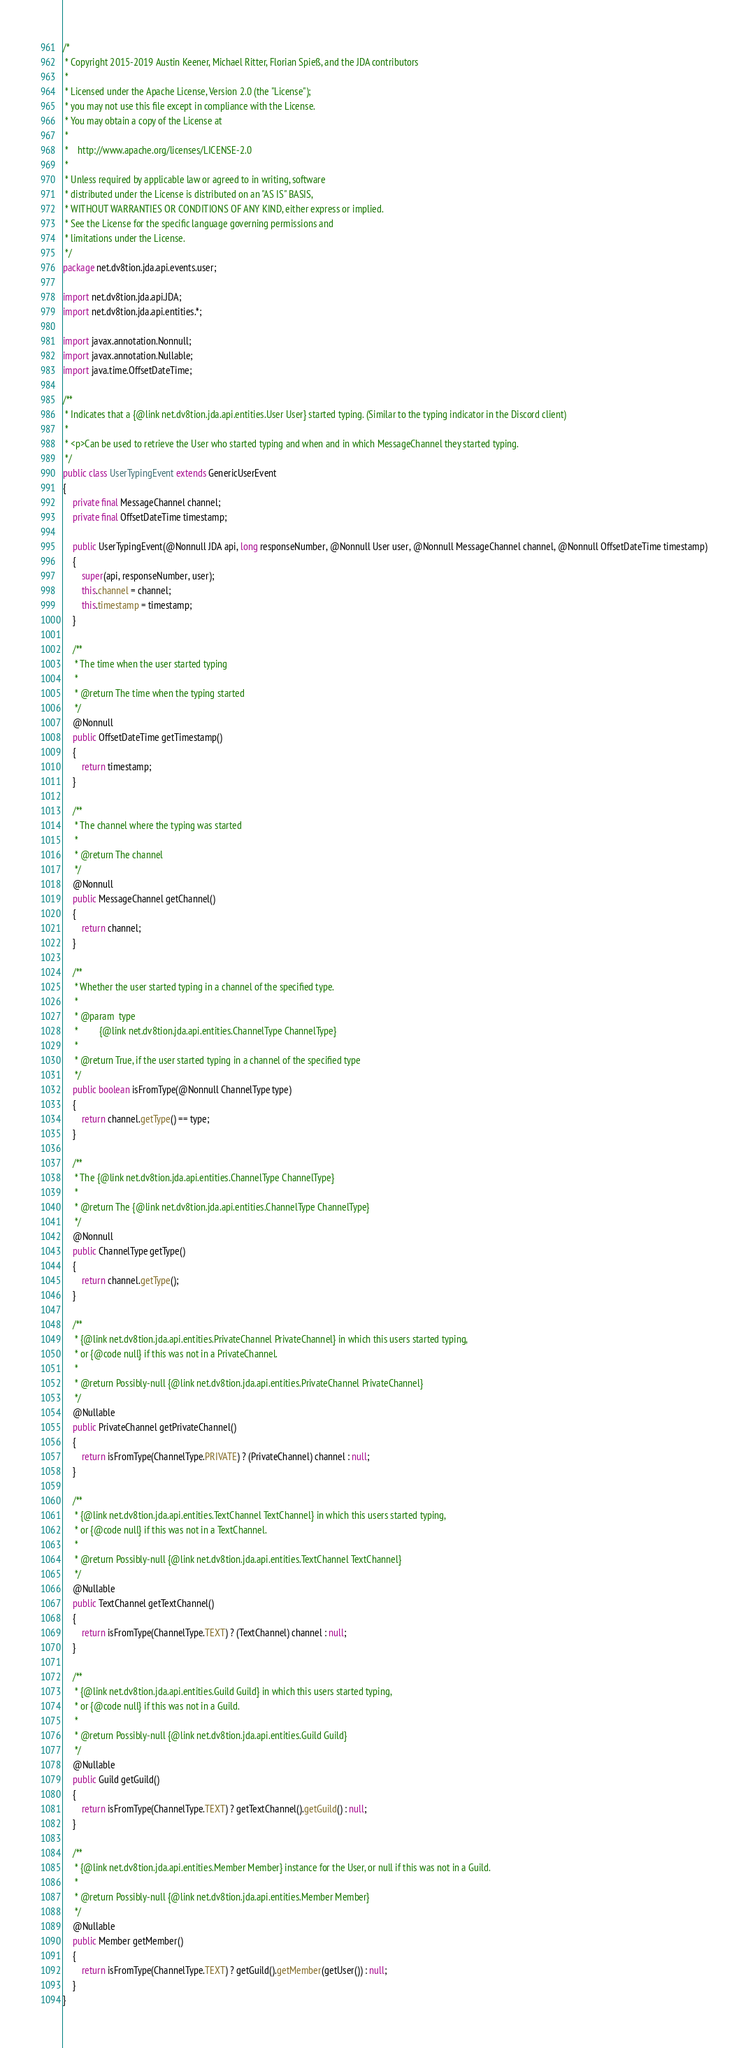<code> <loc_0><loc_0><loc_500><loc_500><_Java_>/*
 * Copyright 2015-2019 Austin Keener, Michael Ritter, Florian Spieß, and the JDA contributors
 *
 * Licensed under the Apache License, Version 2.0 (the "License");
 * you may not use this file except in compliance with the License.
 * You may obtain a copy of the License at
 *
 *    http://www.apache.org/licenses/LICENSE-2.0
 *
 * Unless required by applicable law or agreed to in writing, software
 * distributed under the License is distributed on an "AS IS" BASIS,
 * WITHOUT WARRANTIES OR CONDITIONS OF ANY KIND, either express or implied.
 * See the License for the specific language governing permissions and
 * limitations under the License.
 */
package net.dv8tion.jda.api.events.user;

import net.dv8tion.jda.api.JDA;
import net.dv8tion.jda.api.entities.*;

import javax.annotation.Nonnull;
import javax.annotation.Nullable;
import java.time.OffsetDateTime;

/**
 * Indicates that a {@link net.dv8tion.jda.api.entities.User User} started typing. (Similar to the typing indicator in the Discord client)
 *
 * <p>Can be used to retrieve the User who started typing and when and in which MessageChannel they started typing.
 */
public class UserTypingEvent extends GenericUserEvent
{
    private final MessageChannel channel;
    private final OffsetDateTime timestamp;

    public UserTypingEvent(@Nonnull JDA api, long responseNumber, @Nonnull User user, @Nonnull MessageChannel channel, @Nonnull OffsetDateTime timestamp)
    {
        super(api, responseNumber, user);
        this.channel = channel;
        this.timestamp = timestamp;
    }

    /**
     * The time when the user started typing
     *
     * @return The time when the typing started
     */
    @Nonnull
    public OffsetDateTime getTimestamp()
    {
        return timestamp;
    }

    /**
     * The channel where the typing was started
     *
     * @return The channel
     */
    @Nonnull
    public MessageChannel getChannel()
    {
        return channel;
    }

    /**
     * Whether the user started typing in a channel of the specified type.
     *
     * @param  type
     *         {@link net.dv8tion.jda.api.entities.ChannelType ChannelType}
     *
     * @return True, if the user started typing in a channel of the specified type
     */
    public boolean isFromType(@Nonnull ChannelType type)
    {
        return channel.getType() == type;
    }

    /**
     * The {@link net.dv8tion.jda.api.entities.ChannelType ChannelType}
     *
     * @return The {@link net.dv8tion.jda.api.entities.ChannelType ChannelType}
     */
    @Nonnull
    public ChannelType getType()
    {
        return channel.getType();
    }

    /**
     * {@link net.dv8tion.jda.api.entities.PrivateChannel PrivateChannel} in which this users started typing,
     * or {@code null} if this was not in a PrivateChannel.
     *
     * @return Possibly-null {@link net.dv8tion.jda.api.entities.PrivateChannel PrivateChannel}
     */
    @Nullable
    public PrivateChannel getPrivateChannel()
    {
        return isFromType(ChannelType.PRIVATE) ? (PrivateChannel) channel : null;
    }

    /**
     * {@link net.dv8tion.jda.api.entities.TextChannel TextChannel} in which this users started typing,
     * or {@code null} if this was not in a TextChannel.
     *
     * @return Possibly-null {@link net.dv8tion.jda.api.entities.TextChannel TextChannel}
     */
    @Nullable
    public TextChannel getTextChannel()
    {
        return isFromType(ChannelType.TEXT) ? (TextChannel) channel : null;
    }

    /**
     * {@link net.dv8tion.jda.api.entities.Guild Guild} in which this users started typing,
     * or {@code null} if this was not in a Guild.
     *
     * @return Possibly-null {@link net.dv8tion.jda.api.entities.Guild Guild}
     */
    @Nullable
    public Guild getGuild()
    {
        return isFromType(ChannelType.TEXT) ? getTextChannel().getGuild() : null;
    }

    /**
     * {@link net.dv8tion.jda.api.entities.Member Member} instance for the User, or null if this was not in a Guild.
     *
     * @return Possibly-null {@link net.dv8tion.jda.api.entities.Member Member}
     */
    @Nullable
    public Member getMember()
    {
        return isFromType(ChannelType.TEXT) ? getGuild().getMember(getUser()) : null;
    }
}
</code> 